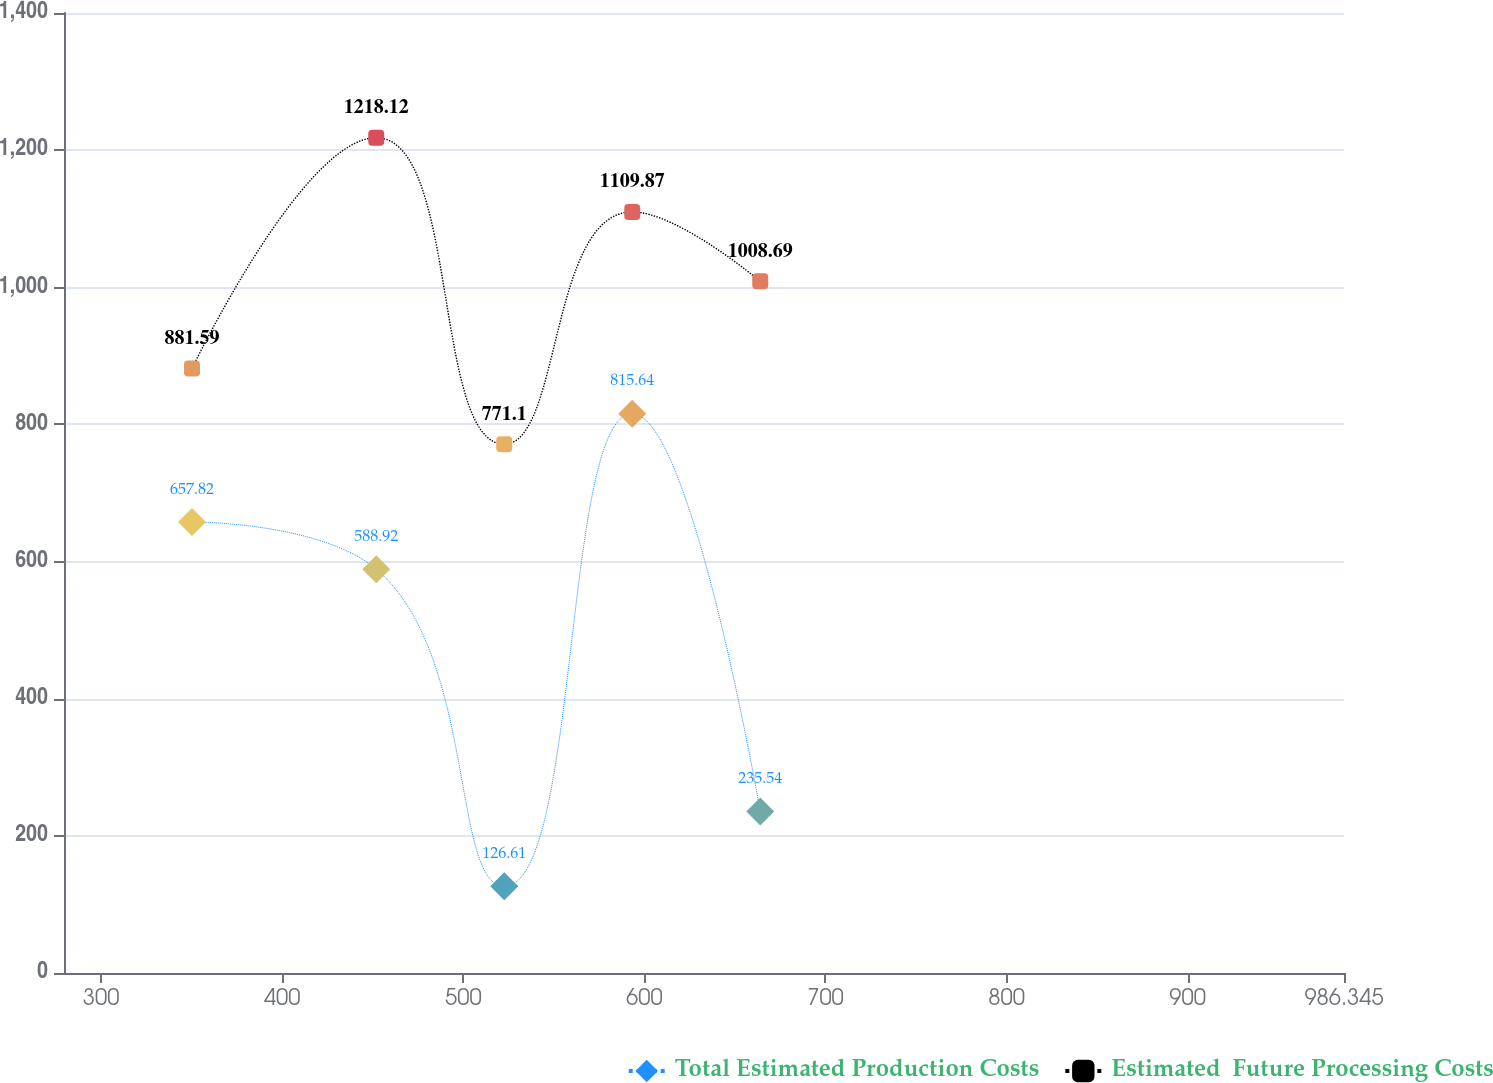Convert chart to OTSL. <chart><loc_0><loc_0><loc_500><loc_500><line_chart><ecel><fcel>Total Estimated Production Costs<fcel>Estimated  Future Processing Costs<nl><fcel>350.18<fcel>657.82<fcel>881.59<nl><fcel>451.93<fcel>588.92<fcel>1218.12<nl><fcel>522.62<fcel>126.61<fcel>771.1<nl><fcel>593.3<fcel>815.64<fcel>1109.87<nl><fcel>663.98<fcel>235.54<fcel>1008.69<nl><fcel>1057.03<fcel>520.02<fcel>1154.57<nl></chart> 